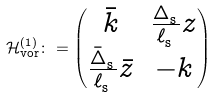<formula> <loc_0><loc_0><loc_500><loc_500>\mathcal { H } ^ { ( 1 ) } _ { \text {vor} } \colon = \begin{pmatrix} \bar { k } & \frac { \Delta ^ { \ } _ { \text {s} } } { \ell ^ { \ } _ { \text {s} } } z \\ \frac { \bar { \Delta } ^ { \ } _ { \text {s} } } { \ell ^ { \ } _ { \text {s} } } \bar { z } & - k \end{pmatrix}</formula> 